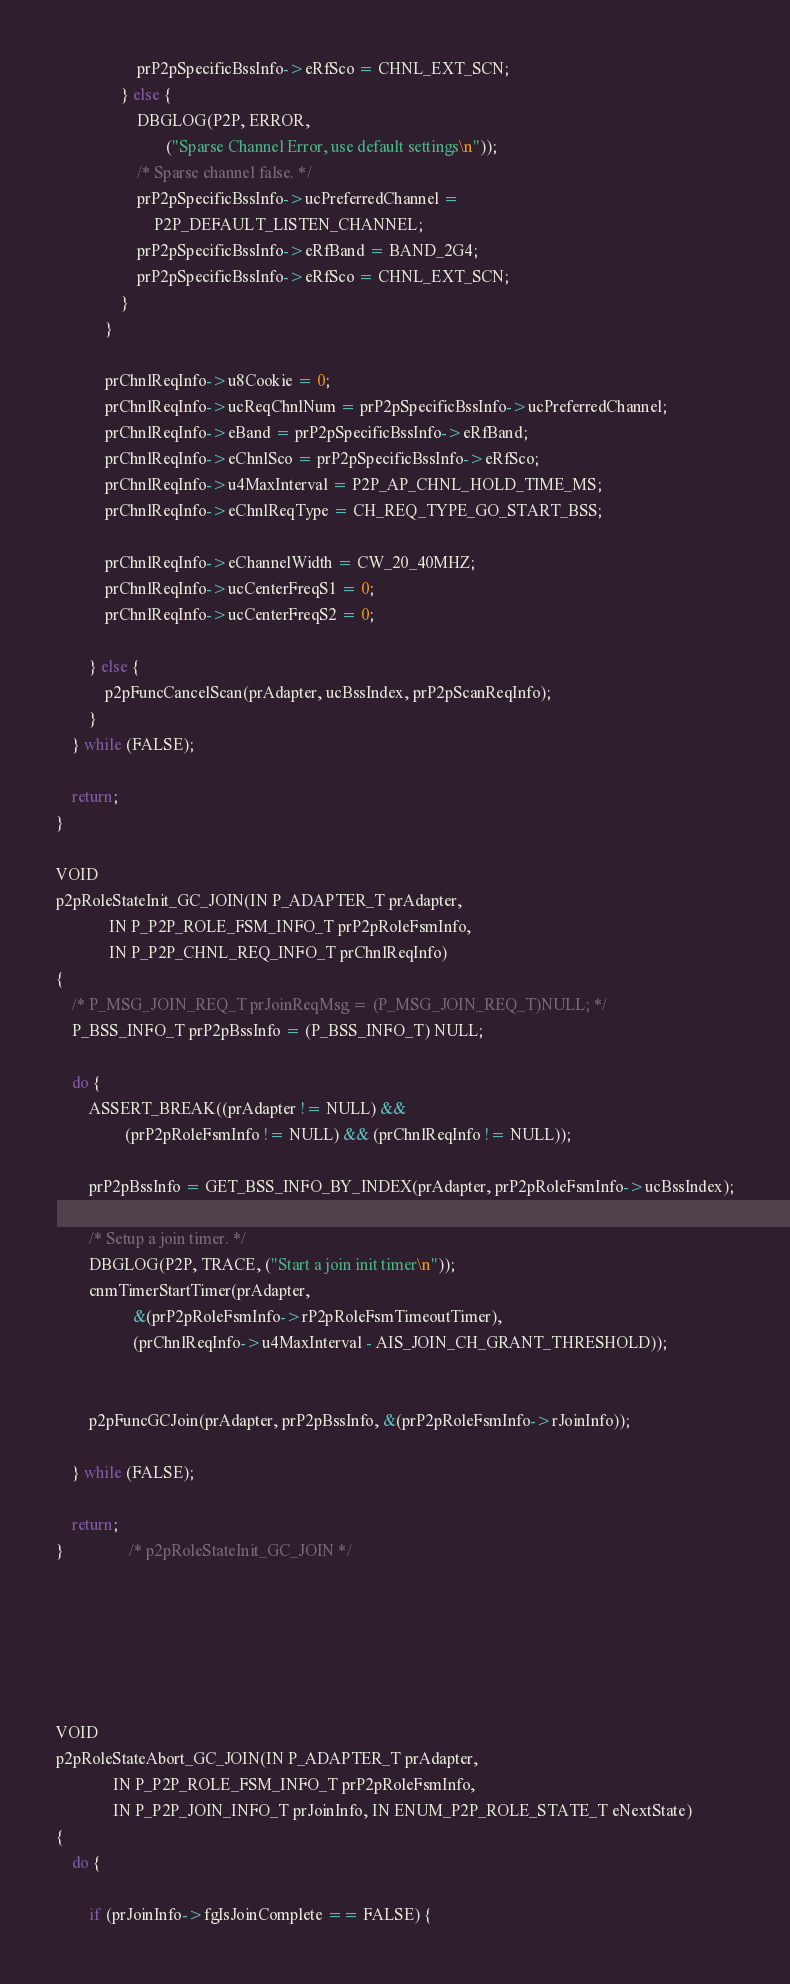<code> <loc_0><loc_0><loc_500><loc_500><_C_>					prP2pSpecificBssInfo->eRfSco = CHNL_EXT_SCN;
				} else {
					DBGLOG(P2P, ERROR,
					       ("Sparse Channel Error, use default settings\n"));
					/* Sparse channel false. */
					prP2pSpecificBssInfo->ucPreferredChannel =
					    P2P_DEFAULT_LISTEN_CHANNEL;
					prP2pSpecificBssInfo->eRfBand = BAND_2G4;
					prP2pSpecificBssInfo->eRfSco = CHNL_EXT_SCN;
				}
			}

			prChnlReqInfo->u8Cookie = 0;
			prChnlReqInfo->ucReqChnlNum = prP2pSpecificBssInfo->ucPreferredChannel;
			prChnlReqInfo->eBand = prP2pSpecificBssInfo->eRfBand;
			prChnlReqInfo->eChnlSco = prP2pSpecificBssInfo->eRfSco;
			prChnlReqInfo->u4MaxInterval = P2P_AP_CHNL_HOLD_TIME_MS;
			prChnlReqInfo->eChnlReqType = CH_REQ_TYPE_GO_START_BSS;

			prChnlReqInfo->eChannelWidth = CW_20_40MHZ;
			prChnlReqInfo->ucCenterFreqS1 = 0;
			prChnlReqInfo->ucCenterFreqS2 = 0;

		} else {
			p2pFuncCancelScan(prAdapter, ucBssIndex, prP2pScanReqInfo);
		}
	} while (FALSE);

	return;
}

VOID
p2pRoleStateInit_GC_JOIN(IN P_ADAPTER_T prAdapter,
			 IN P_P2P_ROLE_FSM_INFO_T prP2pRoleFsmInfo,
			 IN P_P2P_CHNL_REQ_INFO_T prChnlReqInfo)
{
	/* P_MSG_JOIN_REQ_T prJoinReqMsg = (P_MSG_JOIN_REQ_T)NULL; */
	P_BSS_INFO_T prP2pBssInfo = (P_BSS_INFO_T) NULL;

	do {
		ASSERT_BREAK((prAdapter != NULL) &&
			     (prP2pRoleFsmInfo != NULL) && (prChnlReqInfo != NULL));

		prP2pBssInfo = GET_BSS_INFO_BY_INDEX(prAdapter, prP2pRoleFsmInfo->ucBssIndex);

		/* Setup a join timer. */
		DBGLOG(P2P, TRACE, ("Start a join init timer\n"));
		cnmTimerStartTimer(prAdapter,
				   &(prP2pRoleFsmInfo->rP2pRoleFsmTimeoutTimer),
				   (prChnlReqInfo->u4MaxInterval - AIS_JOIN_CH_GRANT_THRESHOLD));


		p2pFuncGCJoin(prAdapter, prP2pBssInfo, &(prP2pRoleFsmInfo->rJoinInfo));

	} while (FALSE);

	return;
}				/* p2pRoleStateInit_GC_JOIN */






VOID
p2pRoleStateAbort_GC_JOIN(IN P_ADAPTER_T prAdapter,
			  IN P_P2P_ROLE_FSM_INFO_T prP2pRoleFsmInfo,
			  IN P_P2P_JOIN_INFO_T prJoinInfo, IN ENUM_P2P_ROLE_STATE_T eNextState)
{
	do {

		if (prJoinInfo->fgIsJoinComplete == FALSE) {</code> 